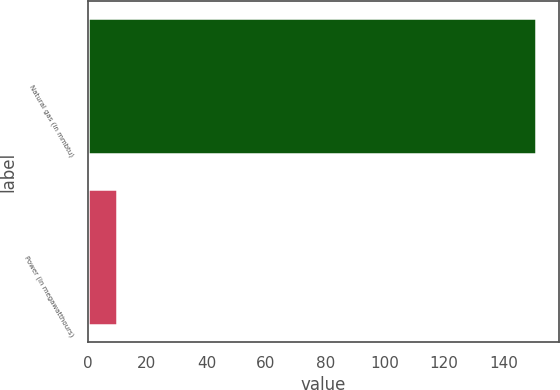<chart> <loc_0><loc_0><loc_500><loc_500><bar_chart><fcel>Natural gas (in mmbtu)<fcel>Power (in megawatthours)<nl><fcel>151<fcel>10<nl></chart> 